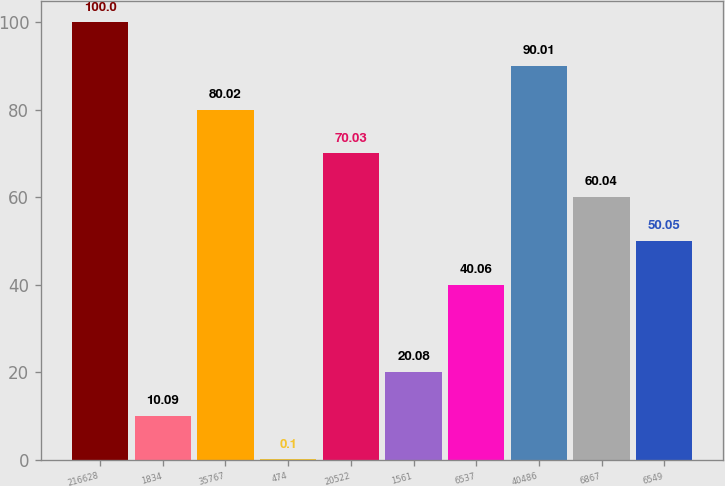<chart> <loc_0><loc_0><loc_500><loc_500><bar_chart><fcel>216628<fcel>1834<fcel>35767<fcel>474<fcel>20522<fcel>1561<fcel>6537<fcel>40486<fcel>6867<fcel>6549<nl><fcel>100<fcel>10.09<fcel>80.02<fcel>0.1<fcel>70.03<fcel>20.08<fcel>40.06<fcel>90.01<fcel>60.04<fcel>50.05<nl></chart> 